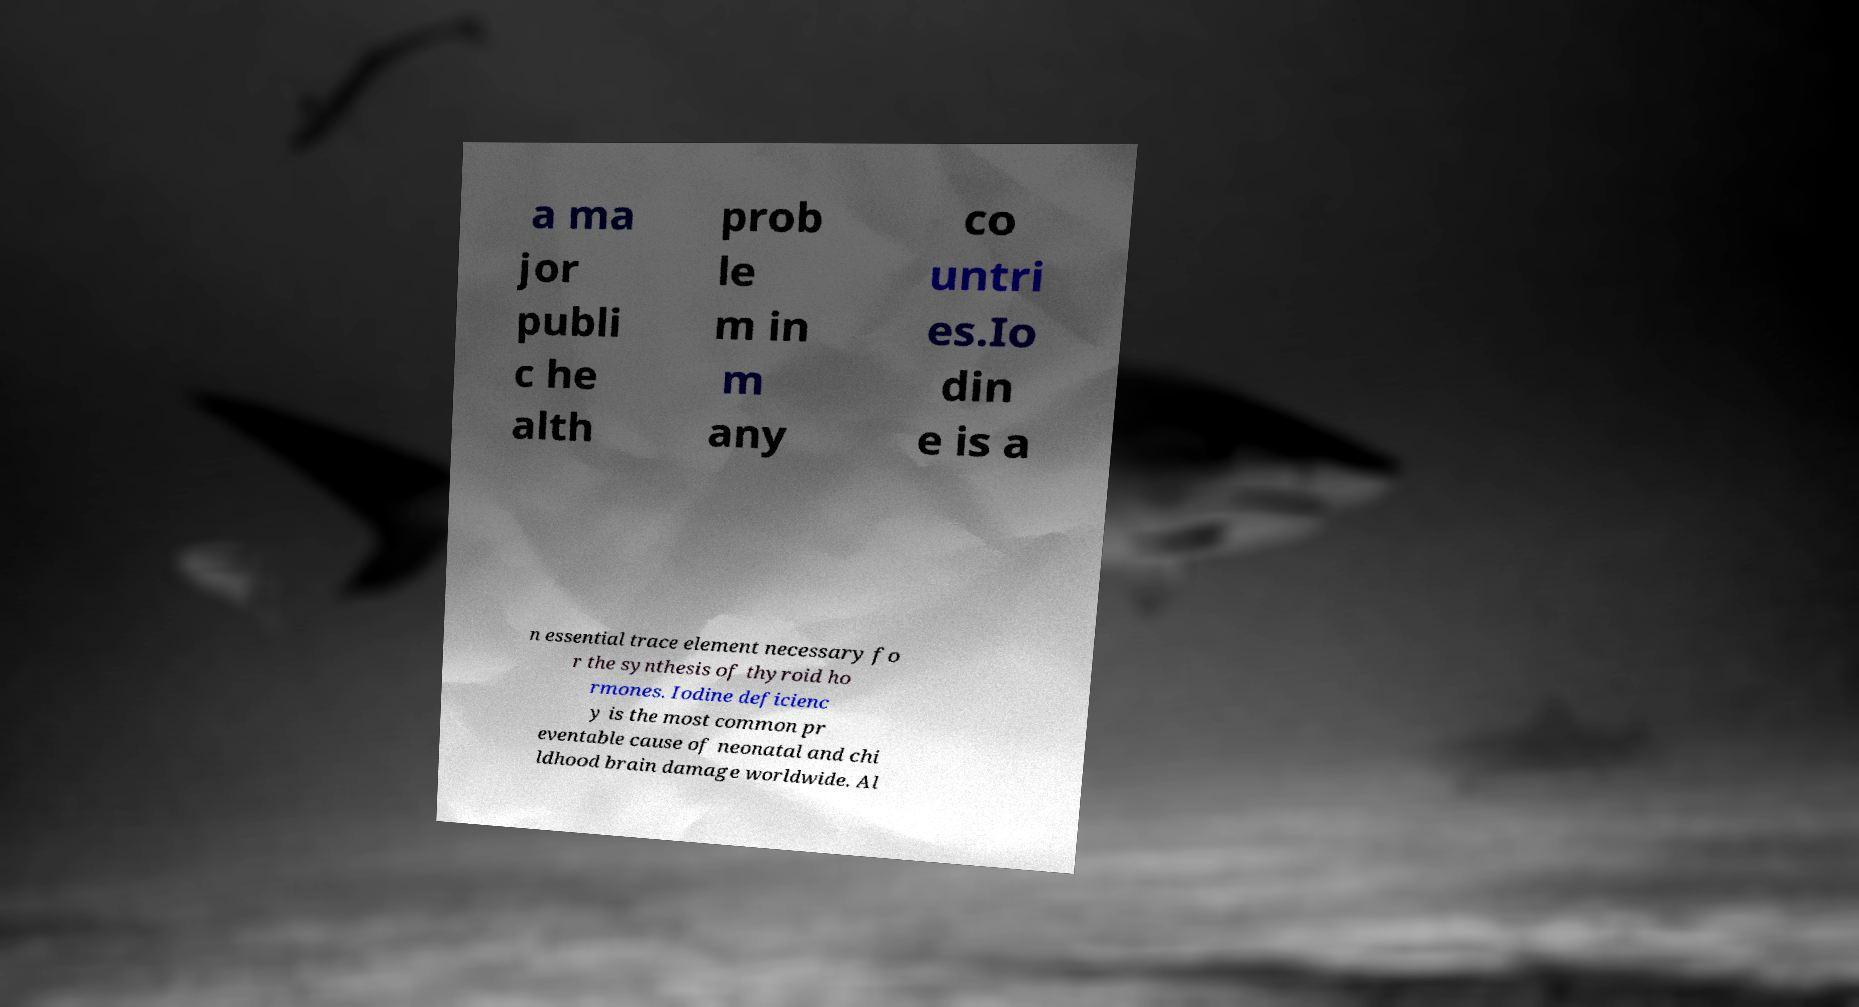There's text embedded in this image that I need extracted. Can you transcribe it verbatim? a ma jor publi c he alth prob le m in m any co untri es.Io din e is a n essential trace element necessary fo r the synthesis of thyroid ho rmones. Iodine deficienc y is the most common pr eventable cause of neonatal and chi ldhood brain damage worldwide. Al 